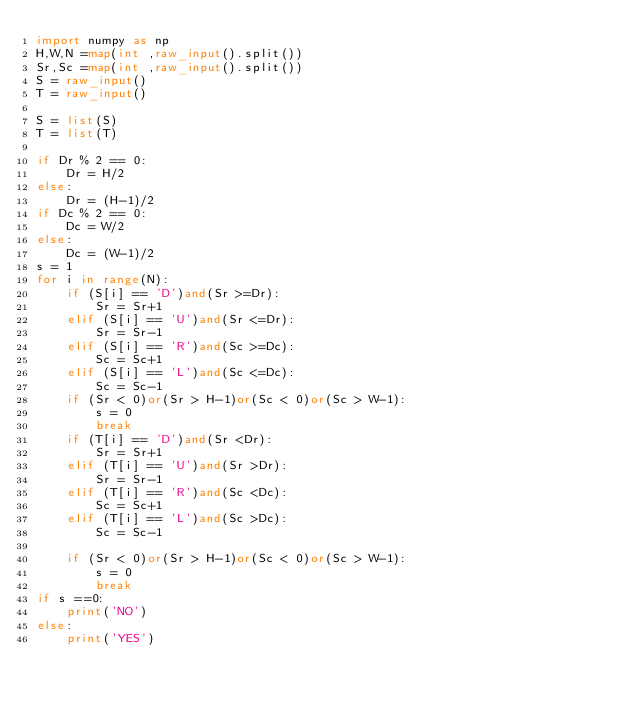Convert code to text. <code><loc_0><loc_0><loc_500><loc_500><_Python_>import numpy as np
H,W,N =map(int ,raw_input().split())
Sr,Sc =map(int ,raw_input().split())
S = raw_input()
T = raw_input()

S = list(S)
T = list(T)

if Dr % 2 == 0:
    Dr = H/2
else:
    Dr = (H-1)/2
if Dc % 2 == 0:
    Dc = W/2
else:
    Dc = (W-1)/2 
s = 1
for i in range(N):
    if (S[i] == 'D')and(Sr >=Dr):
        Sr = Sr+1
    elif (S[i] == 'U')and(Sr <=Dr):
        Sr = Sr-1
    elif (S[i] == 'R')and(Sc >=Dc):
        Sc = Sc+1
    elif (S[i] == 'L')and(Sc <=Dc):
        Sc = Sc-1
    if (Sr < 0)or(Sr > H-1)or(Sc < 0)or(Sc > W-1):
        s = 0
        break
    if (T[i] == 'D')and(Sr <Dr):
        Sr = Sr+1
    elif (T[i] == 'U')and(Sr >Dr):
        Sr = Sr-1
    elif (T[i] == 'R')and(Sc <Dc):
        Sc = Sc+1
    elif (T[i] == 'L')and(Sc >Dc):
        Sc = Sc-1
    
    if (Sr < 0)or(Sr > H-1)or(Sc < 0)or(Sc > W-1):
        s = 0
        break
if s ==0:
    print('NO')
else:
    print('YES')</code> 